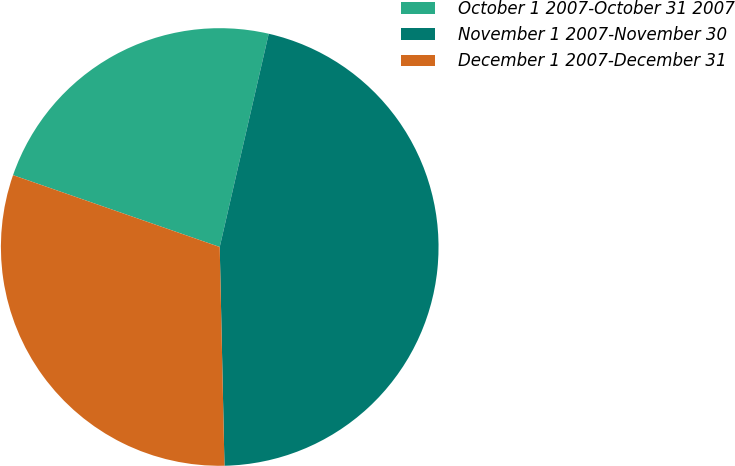Convert chart to OTSL. <chart><loc_0><loc_0><loc_500><loc_500><pie_chart><fcel>October 1 2007-October 31 2007<fcel>November 1 2007-November 30<fcel>December 1 2007-December 31<nl><fcel>23.27%<fcel>46.06%<fcel>30.67%<nl></chart> 